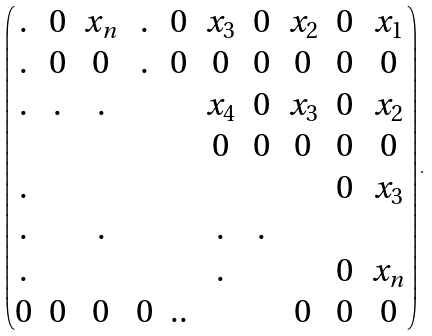<formula> <loc_0><loc_0><loc_500><loc_500>\left ( \begin{matrix} . & 0 & x _ { n } & . & 0 & x _ { 3 } & 0 & x _ { 2 } & 0 & x _ { 1 } \\ . & 0 & 0 & . & 0 & 0 & 0 & 0 & 0 & 0 \\ . & . & . & & & x _ { 4 } & 0 & x _ { 3 } & 0 & x _ { 2 } \\ & & & & & 0 & 0 & 0 & 0 & 0 \\ . & & & & & & & & 0 & x _ { 3 } \\ . & & . & & & . & . \\ . & & & & & . & & & 0 & x _ { n } \\ 0 & 0 & 0 & 0 & . . & & & 0 & 0 & 0 \end{matrix} \right ) .</formula> 